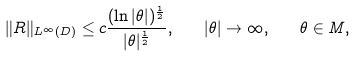<formula> <loc_0><loc_0><loc_500><loc_500>\| R \| _ { L ^ { \infty } ( D ) } \leq c \frac { ( \ln | \theta | ) ^ { \frac { 1 } { 2 } } } { | \theta | ^ { \frac { 1 } { 2 } } } , \quad | \theta | \to \infty , \quad \theta \in M ,</formula> 